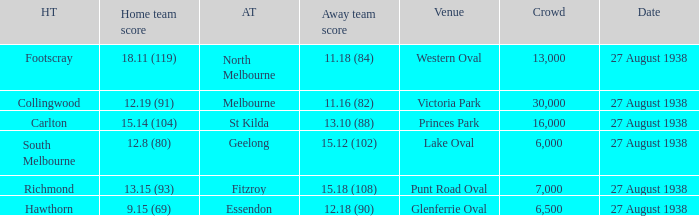Which Team plays at Western Oval? Footscray. 